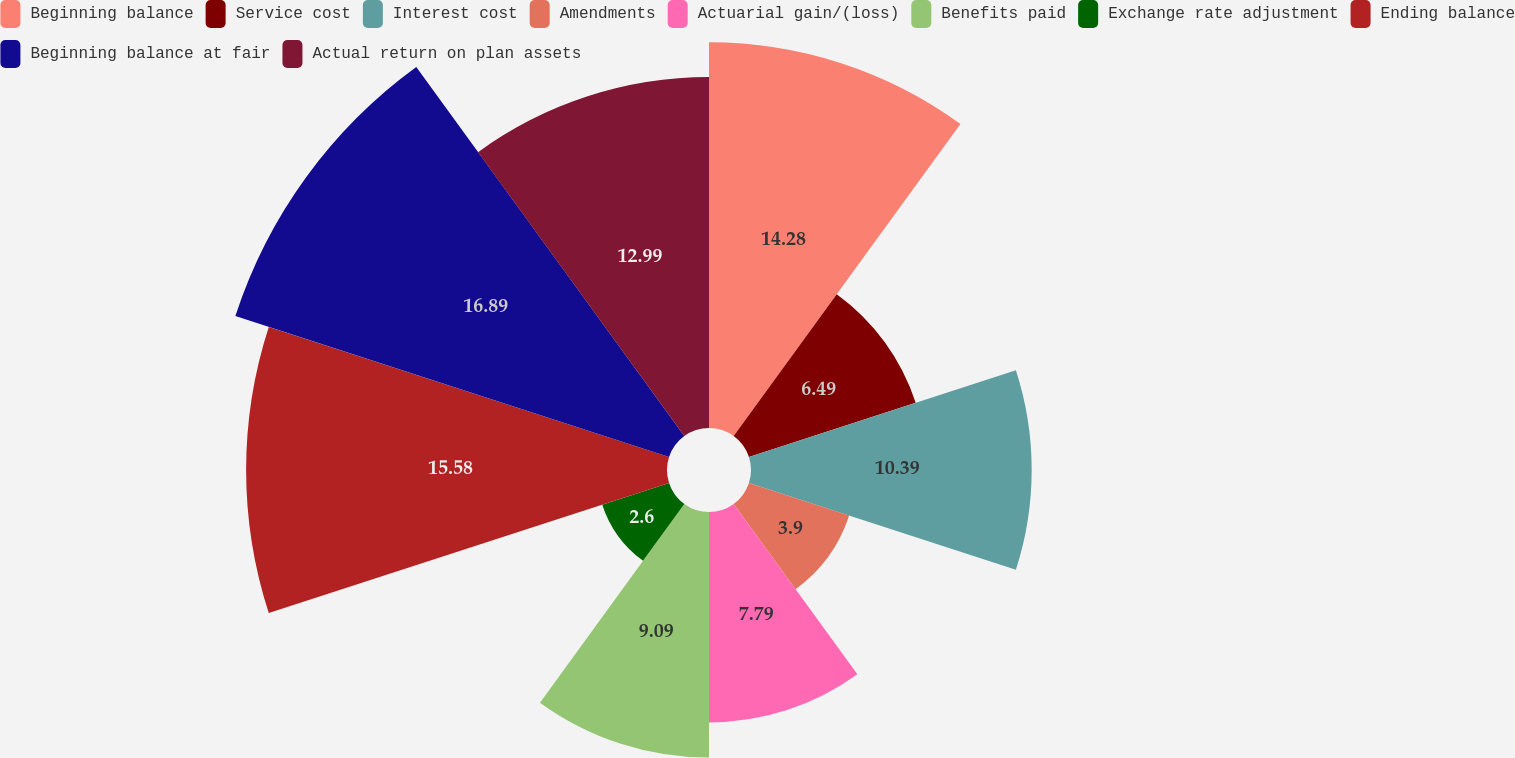Convert chart. <chart><loc_0><loc_0><loc_500><loc_500><pie_chart><fcel>Beginning balance<fcel>Service cost<fcel>Interest cost<fcel>Amendments<fcel>Actuarial gain/(loss)<fcel>Benefits paid<fcel>Exchange rate adjustment<fcel>Ending balance<fcel>Beginning balance at fair<fcel>Actual return on plan assets<nl><fcel>14.28%<fcel>6.49%<fcel>10.39%<fcel>3.9%<fcel>7.79%<fcel>9.09%<fcel>2.6%<fcel>15.58%<fcel>16.88%<fcel>12.99%<nl></chart> 